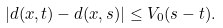<formula> <loc_0><loc_0><loc_500><loc_500>| d ( x , t ) - d ( x , s ) | \leq V _ { 0 } ( s - t ) .</formula> 